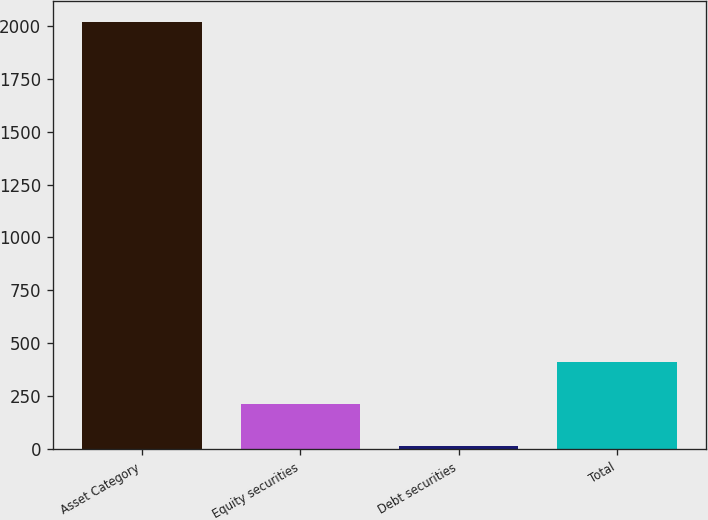<chart> <loc_0><loc_0><loc_500><loc_500><bar_chart><fcel>Asset Category<fcel>Equity securities<fcel>Debt securities<fcel>Total<nl><fcel>2016<fcel>214.58<fcel>14.42<fcel>414.74<nl></chart> 